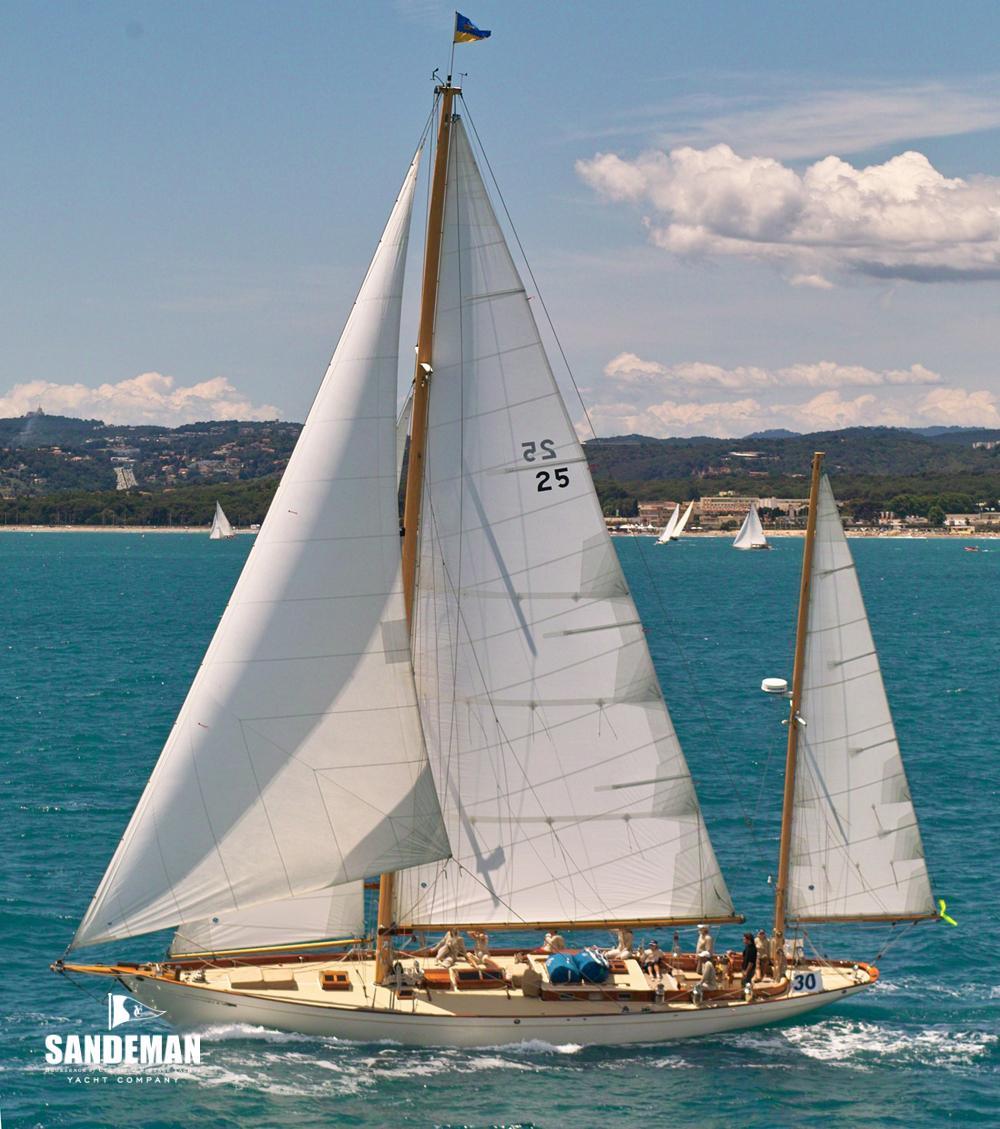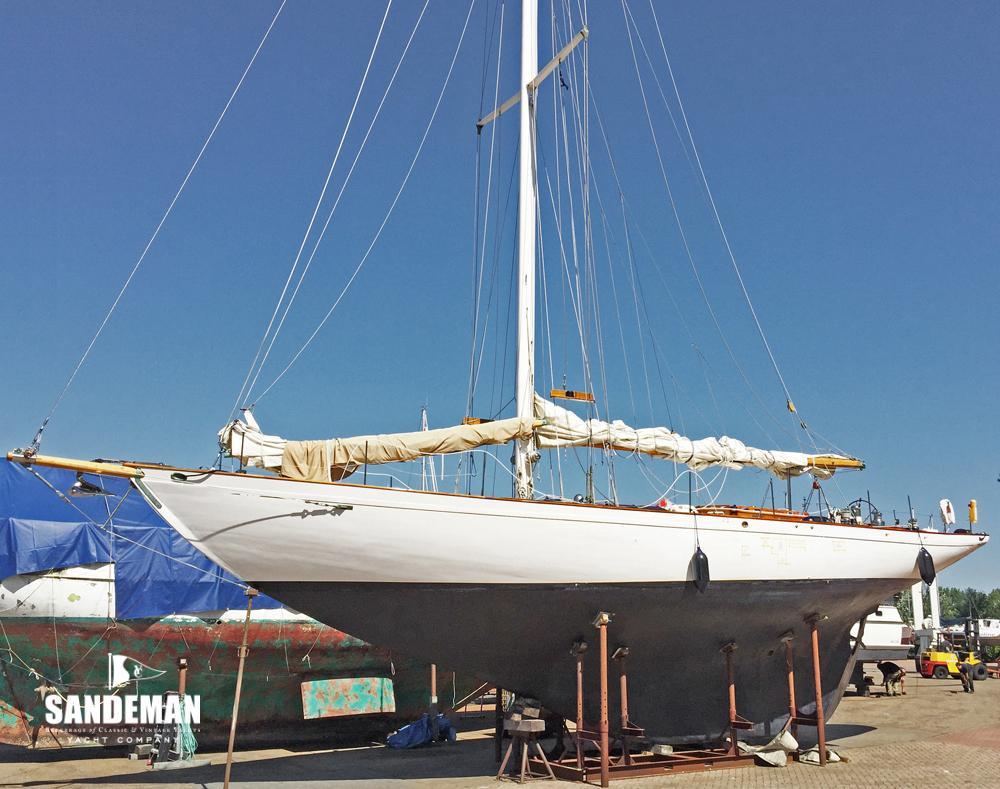The first image is the image on the left, the second image is the image on the right. Assess this claim about the two images: "The left and right image contains the same number of sailboats with there sails down.". Correct or not? Answer yes or no. No. The first image is the image on the left, the second image is the image on the right. Assess this claim about the two images: "One sailboat is sitting on a platform on dry land, while a second sailboat is floating on water.". Correct or not? Answer yes or no. Yes. 